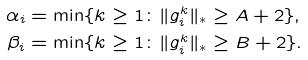Convert formula to latex. <formula><loc_0><loc_0><loc_500><loc_500>\alpha _ { i } & = \min \{ k \geq 1 \colon \| g _ { i } ^ { k } \| _ { * } \geq A + 2 \} , \\ \beta _ { i } & = \min \{ k \geq 1 \colon \| g _ { i } ^ { k } \| _ { * } \geq B + 2 \} .</formula> 